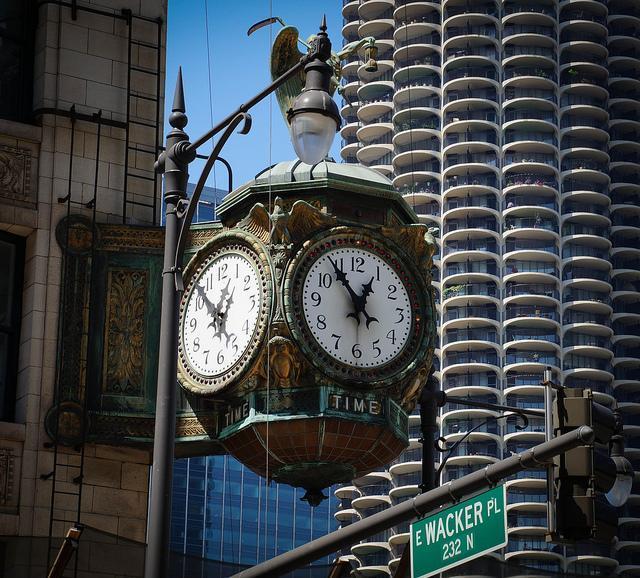How many clock faces?
Give a very brief answer. 2. How many clocks can you see?
Give a very brief answer. 2. 